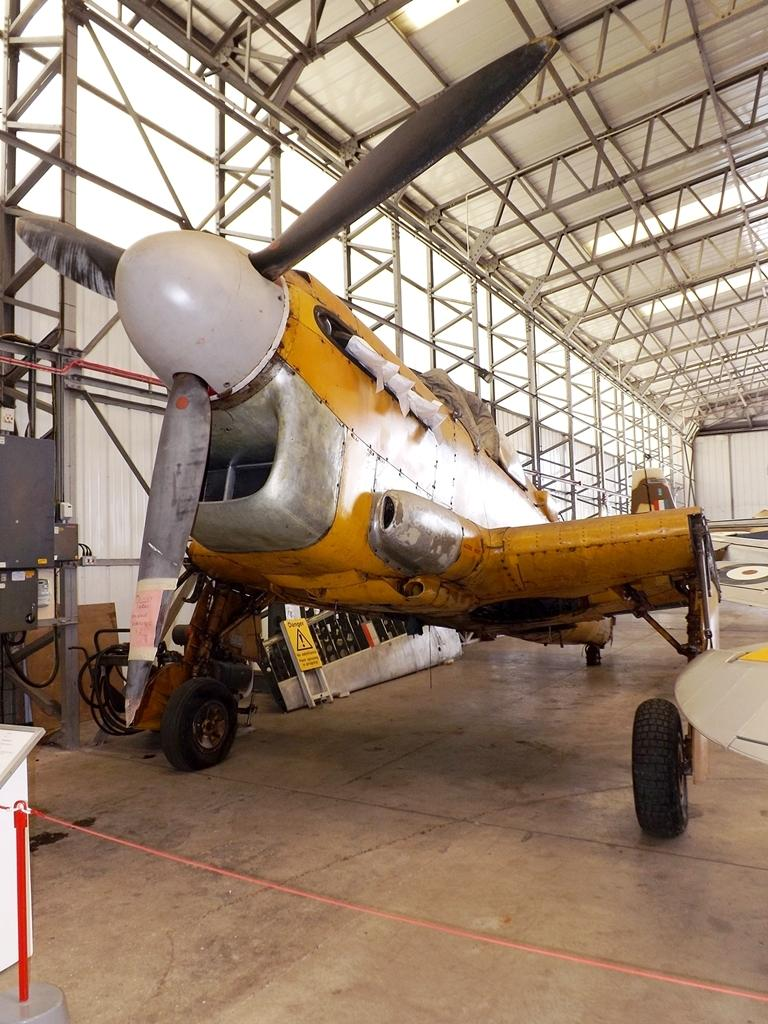What type of vehicle is in the image? There is an old aeroplane in the image. Where is the aeroplane located? The aeroplane is on the floor. In which type of building is the aeroplane situated? The location of the aeroplane is inside a godown. Where is the faucet located in the image? There is no faucet present in the image. 